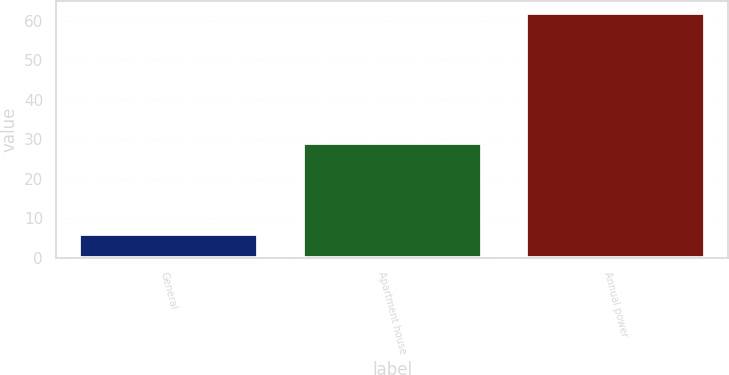Convert chart to OTSL. <chart><loc_0><loc_0><loc_500><loc_500><bar_chart><fcel>General<fcel>Apartment house<fcel>Annual power<nl><fcel>6<fcel>29<fcel>62<nl></chart> 